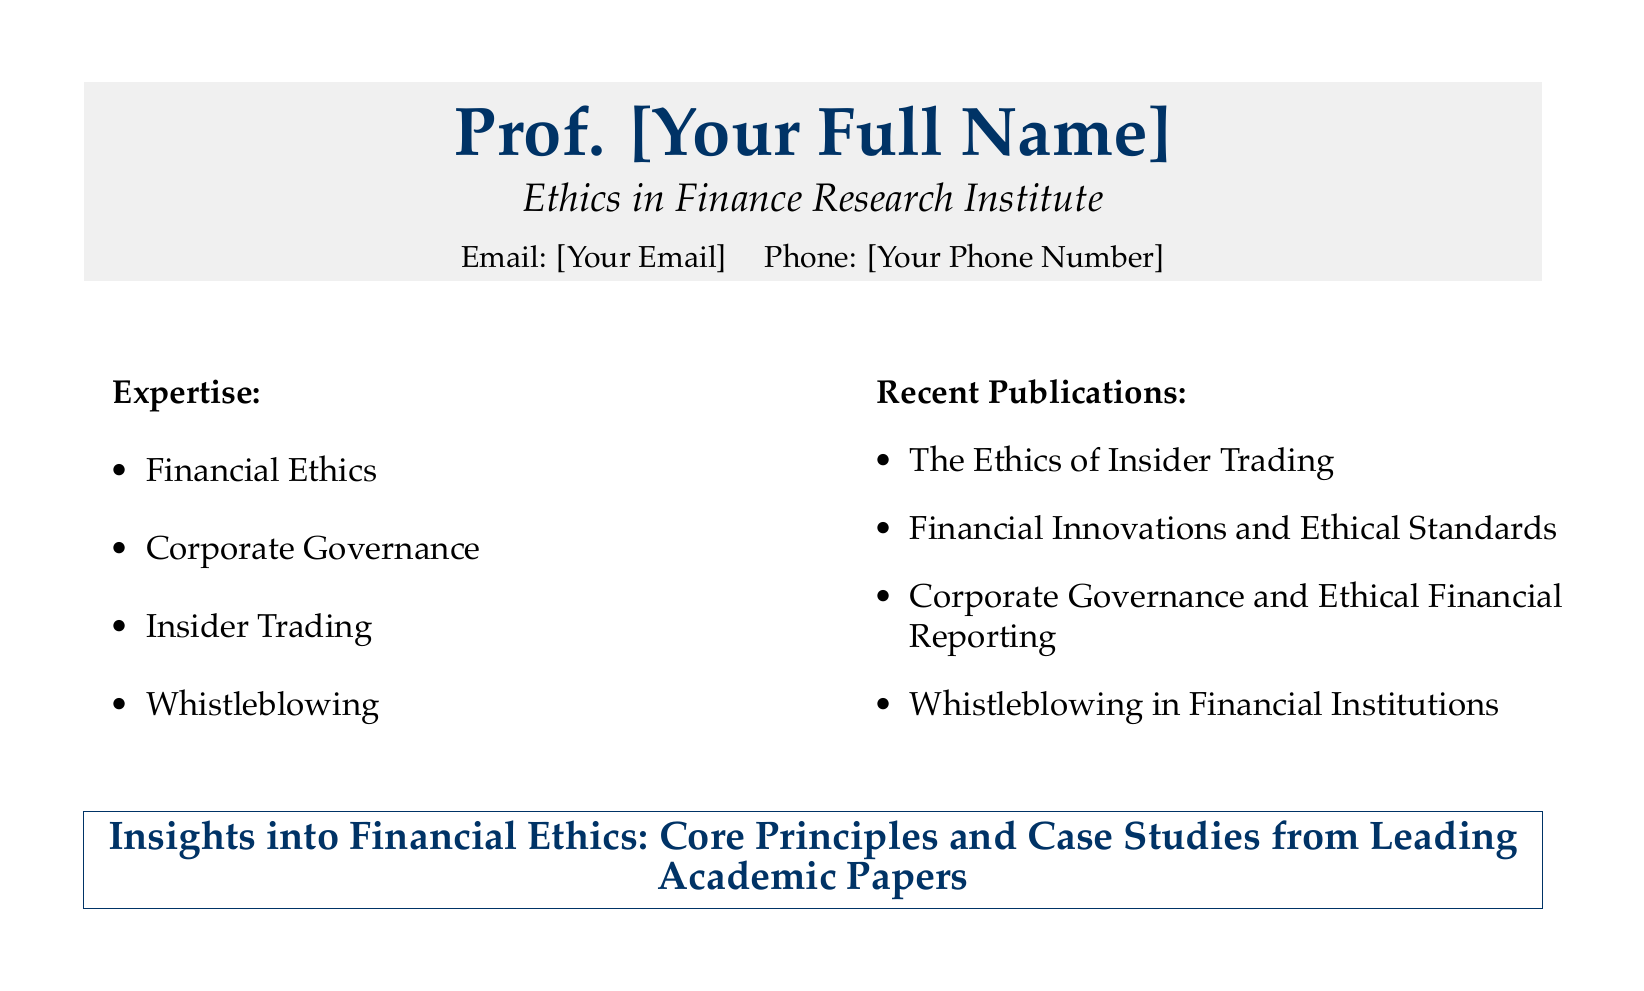What is the professor's title? The title is prominently mentioned at the top of the document, identifying the person as a Professor.
Answer: Professor Where does the professor work? The document suggests an affiliation with an institute focused on ethics in finance.
Answer: Ethics in Finance Research Institute What are two areas of expertise mentioned? The document lists several areas under the expertise section, allowing for the selection of any two.
Answer: Financial Ethics, Corporate Governance Name one recent publication by the professor. The document includes a section listing recent publications, highlighting specific titles authored by the professor.
Answer: The Ethics of Insider Trading What color is used for the professor's name? The color of the name is specified at the top of the card, drawing attention to it.
Answer: Dark blue How many recent publications are listed? The recent publications section explicitly mentions a list that can be easily counted.
Answer: Four What is the focus of the insights presented? The insights title summarizes the coverage of core principles and case studies in financial ethics.
Answer: Financial Ethics Which principle is emphasized alongside case studies? The document indicates that the insights include core principles, which are highlighted in the title area.
Answer: Core Principles 